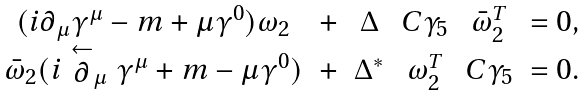Convert formula to latex. <formula><loc_0><loc_0><loc_500><loc_500>\begin{array} { c c c c c c c c } & ( i \partial _ { \mu } \gamma ^ { \mu } - m + \mu \gamma ^ { 0 } ) \omega _ { 2 } & + & \Delta & C \gamma _ { 5 } & { \bar { \omega } } _ { 2 } ^ { T } & = 0 , \\ & { \bar { \omega } } _ { 2 } ( i \stackrel { \leftarrow } { \partial } _ { \mu } \gamma ^ { \mu } + m - \mu \gamma ^ { 0 } ) & + & \Delta ^ { * } & \omega _ { 2 } ^ { T } & C \gamma _ { 5 } & = 0 . \end{array}</formula> 